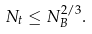<formula> <loc_0><loc_0><loc_500><loc_500>N _ { t } \leq N _ { B } ^ { 2 / 3 } .</formula> 